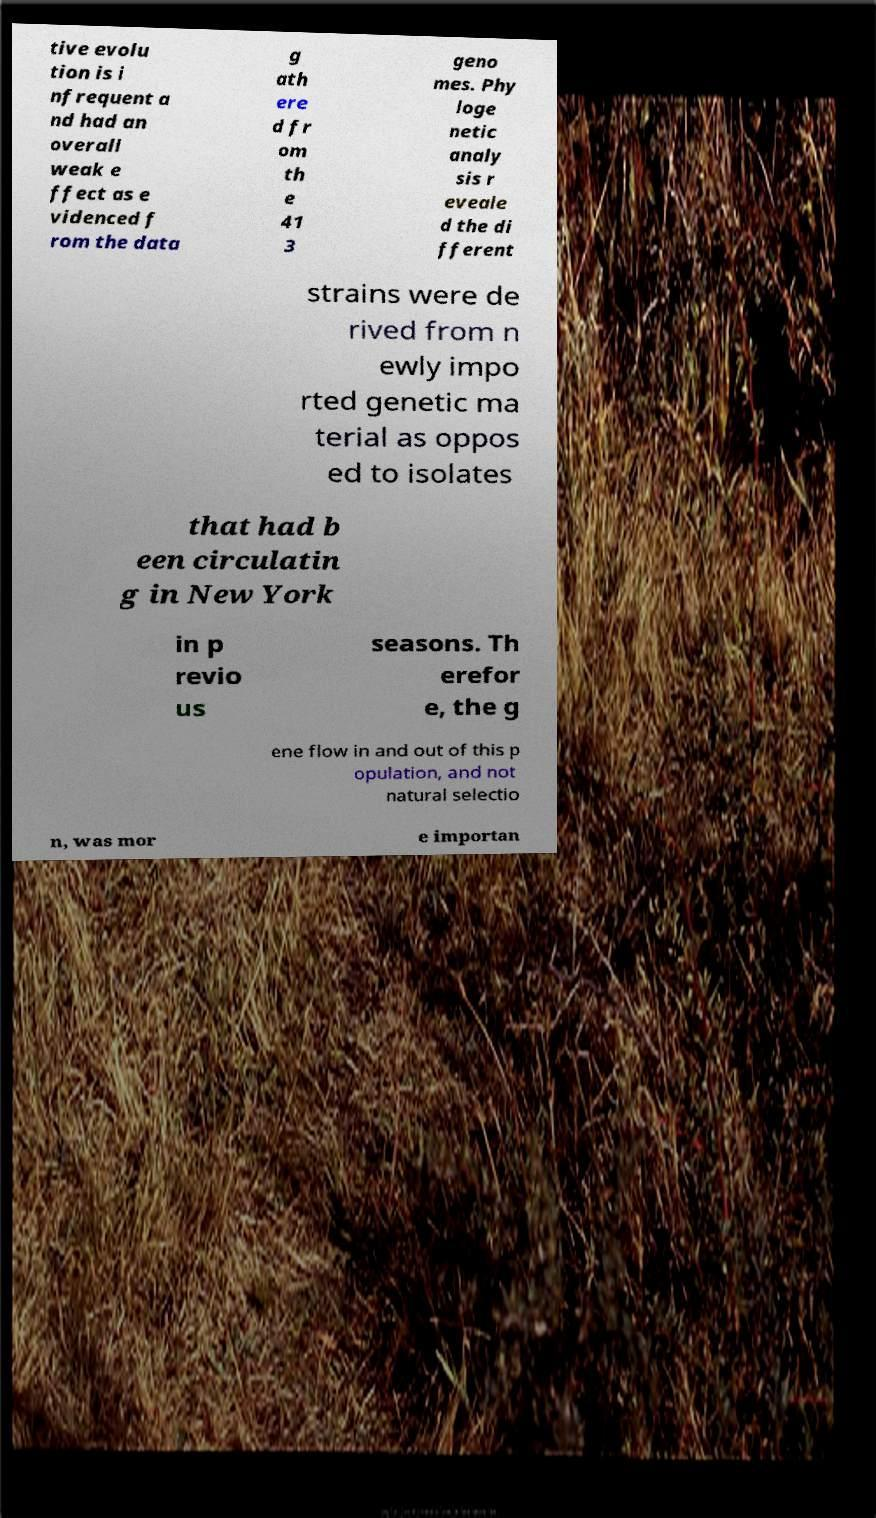For documentation purposes, I need the text within this image transcribed. Could you provide that? tive evolu tion is i nfrequent a nd had an overall weak e ffect as e videnced f rom the data g ath ere d fr om th e 41 3 geno mes. Phy loge netic analy sis r eveale d the di fferent strains were de rived from n ewly impo rted genetic ma terial as oppos ed to isolates that had b een circulatin g in New York in p revio us seasons. Th erefor e, the g ene flow in and out of this p opulation, and not natural selectio n, was mor e importan 